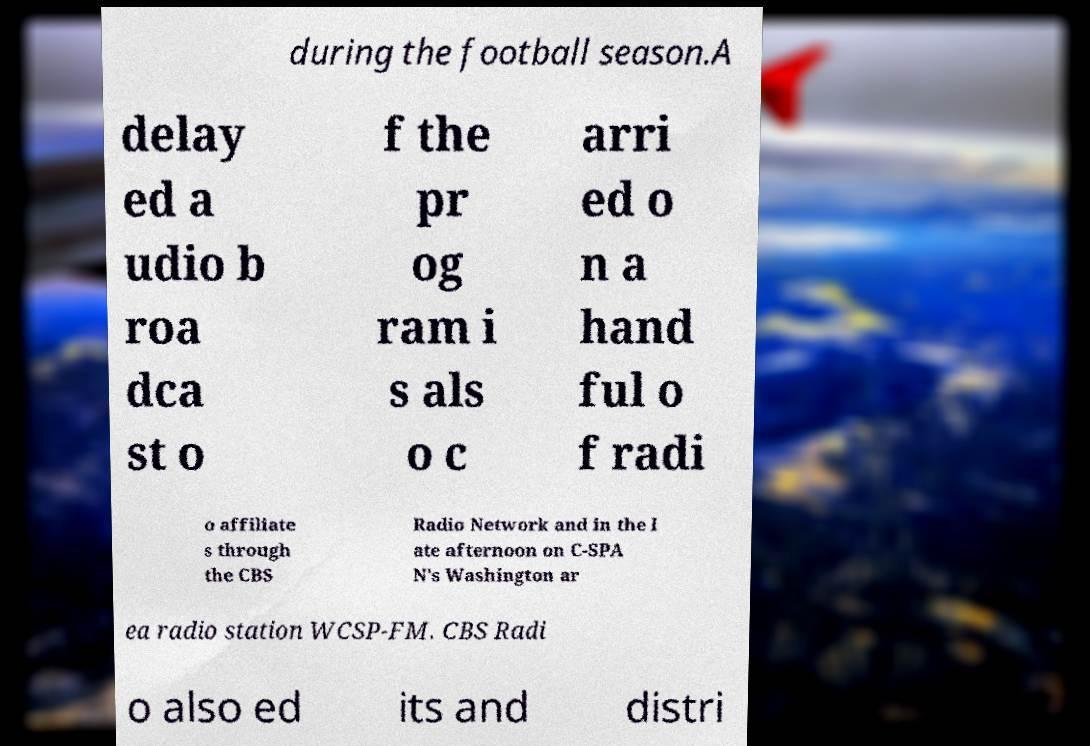What messages or text are displayed in this image? I need them in a readable, typed format. during the football season.A delay ed a udio b roa dca st o f the pr og ram i s als o c arri ed o n a hand ful o f radi o affiliate s through the CBS Radio Network and in the l ate afternoon on C-SPA N's Washington ar ea radio station WCSP-FM. CBS Radi o also ed its and distri 